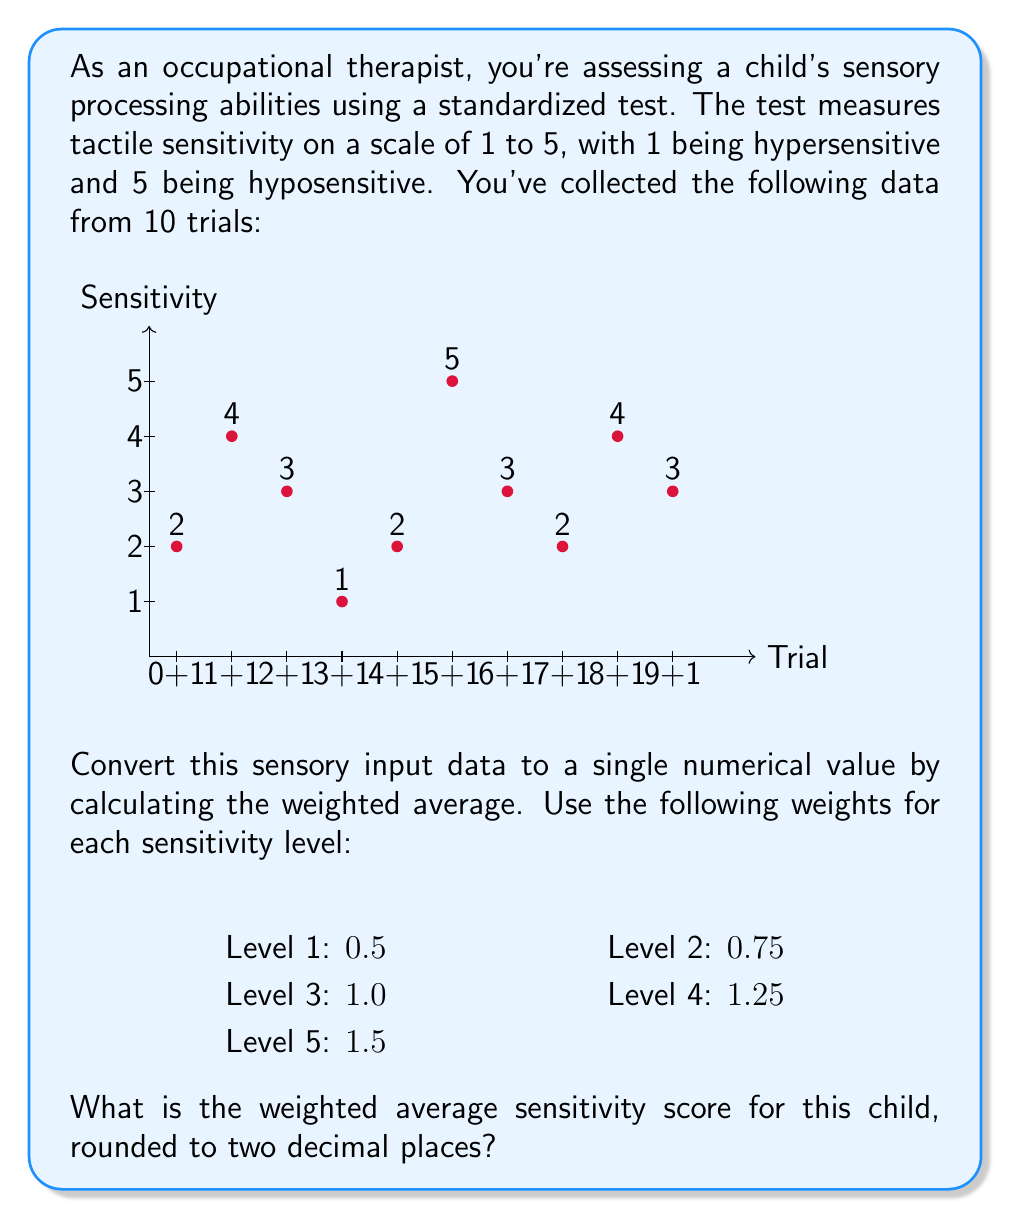Help me with this question. To solve this problem, we'll follow these steps:

1) First, let's count the frequency of each sensitivity level:
   Level 1: 1 time
   Level 2: 3 times
   Level 3: 3 times
   Level 4: 2 times
   Level 5: 1 time

2) Now, we'll multiply each level by its weight and by its frequency:
   Level 1: $1 \times 0.5 \times 1 = 0.5$
   Level 2: $2 \times 0.75 \times 3 = 4.5$
   Level 3: $3 \times 1.0 \times 3 = 9.0$
   Level 4: $4 \times 1.25 \times 2 = 10.0$
   Level 5: $5 \times 1.5 \times 1 = 7.5$

3) Sum up all these values:
   $0.5 + 4.5 + 9.0 + 10.0 + 7.5 = 31.5$

4) Divide by the total number of trials (10):
   $\frac{31.5}{10} = 3.15$

5) The result is already rounded to two decimal places, so this is our final answer.

This weighted average takes into account both the frequency of each sensitivity level and the relative importance (weight) assigned to each level, providing a more nuanced single numerical representation of the child's overall tactile sensitivity.
Answer: 3.15 